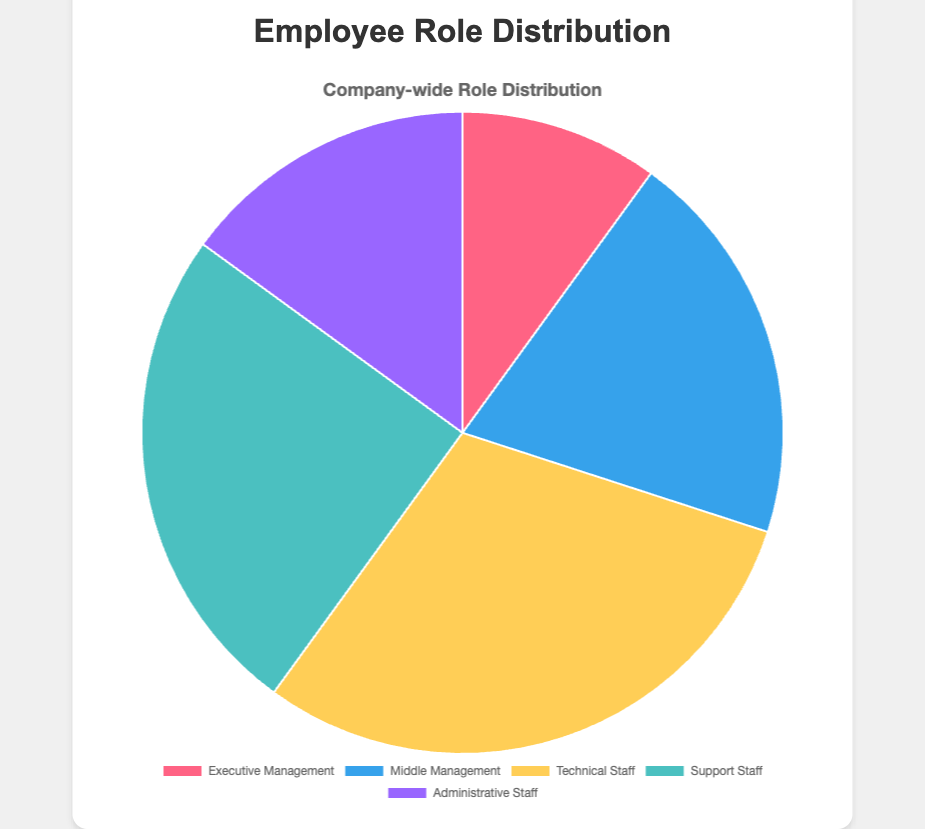Which role has the highest percentage in the distribution? The role with the highest percentage in the distribution can be determined by the segment with the largest proportion in the pie chart. Technical Staff is the largest segment with 30%.
Answer: Technical Staff Which two roles together make up the majority of the workforce? Sum the percentages of each role in pairs to see which combination exceeds 50%. Technical Staff (30%) and Support Staff (25%) together make up 55%, which is more than half.
Answer: Technical Staff and Support Staff What is the percentage difference between Executive Management and Middle Management? Subtract the percentage of Executive Management (10%) from the percentage of Middle Management (20%). 20% - 10% = 10%.
Answer: 10% What is the total percentage of all management roles (Executive and Middle Management)? Add the percentages of Executive Management (10%) and Middle Management (20%). 10% + 20% = 30%.
Answer: 30% What role has the smallest segment, and what is its percentage? Identify the smallest segment visually and check its label. The smallest segment is Executive Management, which is 10%.
Answer: Executive Management If the Administrative Staff percentage is increased by 5%, what would their new percentage be? Add 5% to the current percentage of Administrative Staff (15%). 15% + 5% = 20%.
Answer: 20% How does the percentage of Support Staff compare to the percentage of Administrative Staff? Compare the two percentages: Support Staff is 25%, and Administrative Staff is 15%. Support Staff has a higher percentage.
Answer: Support Staff has a higher percentage What is the cumulative percentage of non-management roles (Technical, Support, and Administrative Staff)? Sum the percentages of Technical Staff (30%), Support Staff (25%), and Administrative Staff (15%). 30% + 25% + 15% = 70%.
Answer: 70% How much larger is the percentage of Technical Staff compared to Administrative Staff? Subtract the percentage of Administrative Staff (15%) from Technical Staff (30%). 30% - 15% = 15%.
Answer: 15% Which color represents the smallest segment in the pie chart? The smallest segment is Executive Management, which is represented by the red color.
Answer: Red 